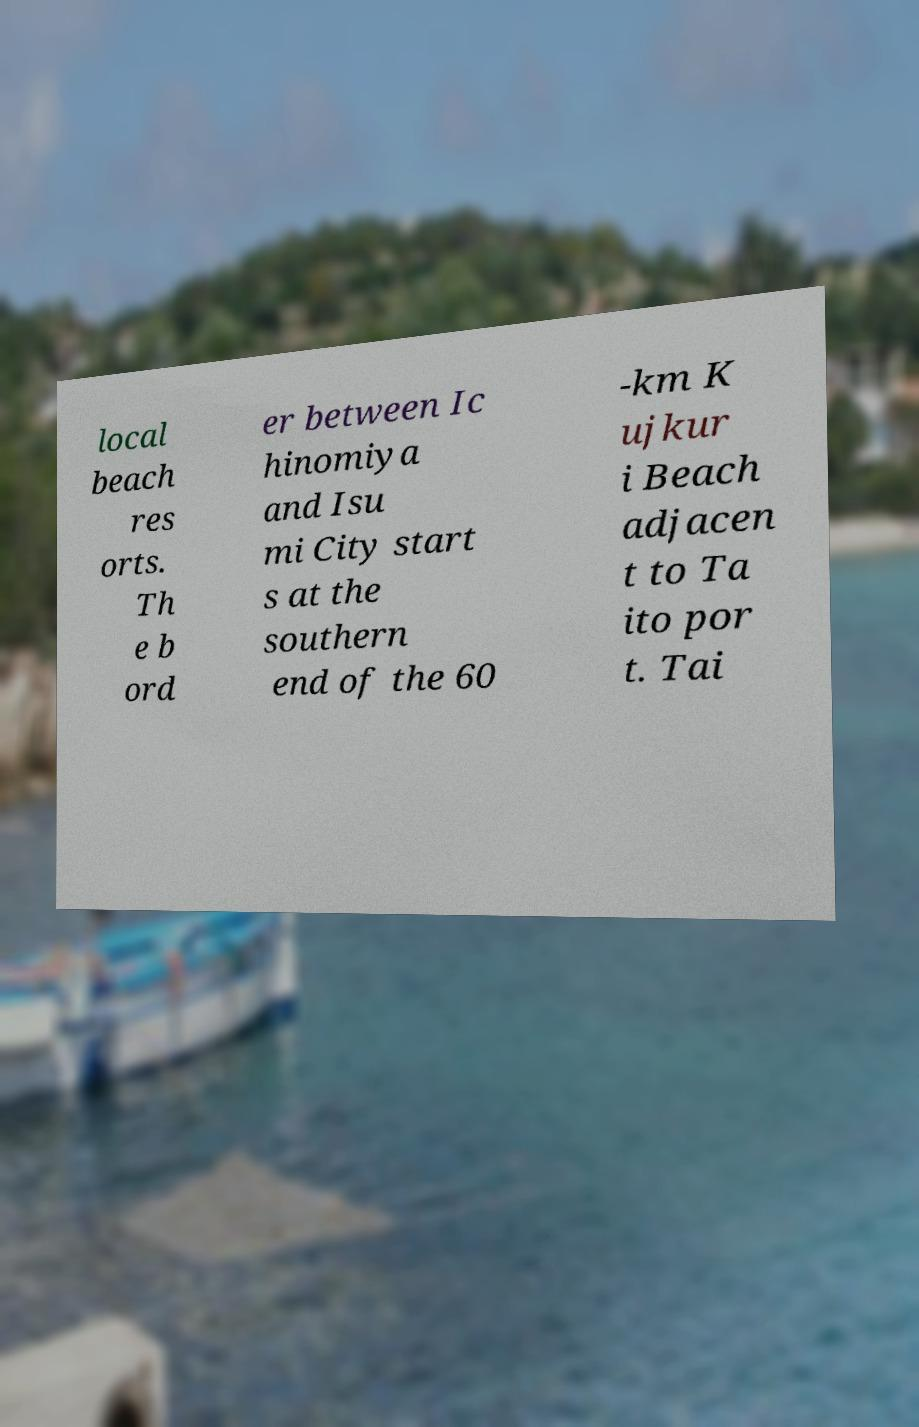Can you accurately transcribe the text from the provided image for me? local beach res orts. Th e b ord er between Ic hinomiya and Isu mi City start s at the southern end of the 60 -km K ujkur i Beach adjacen t to Ta ito por t. Tai 